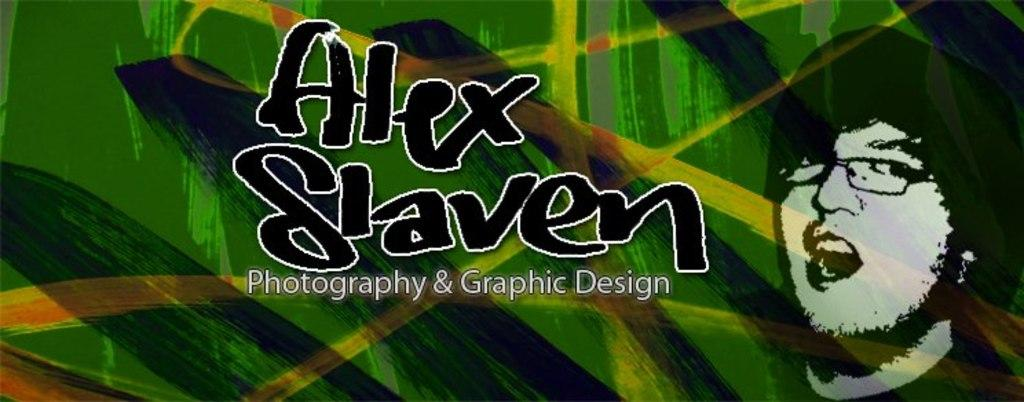What can be found in the image that contains written information? There is text in the image. What is shown in the image besides the text? There is a depiction of a person in the image. What type of zebra can be seen interacting with the person in the image? There is no zebra present in the image; it only contains text and a depiction of a person. What kind of rock is being used by the person in the image? There is no rock visible in the image; it only contains text and a depiction of a person. 